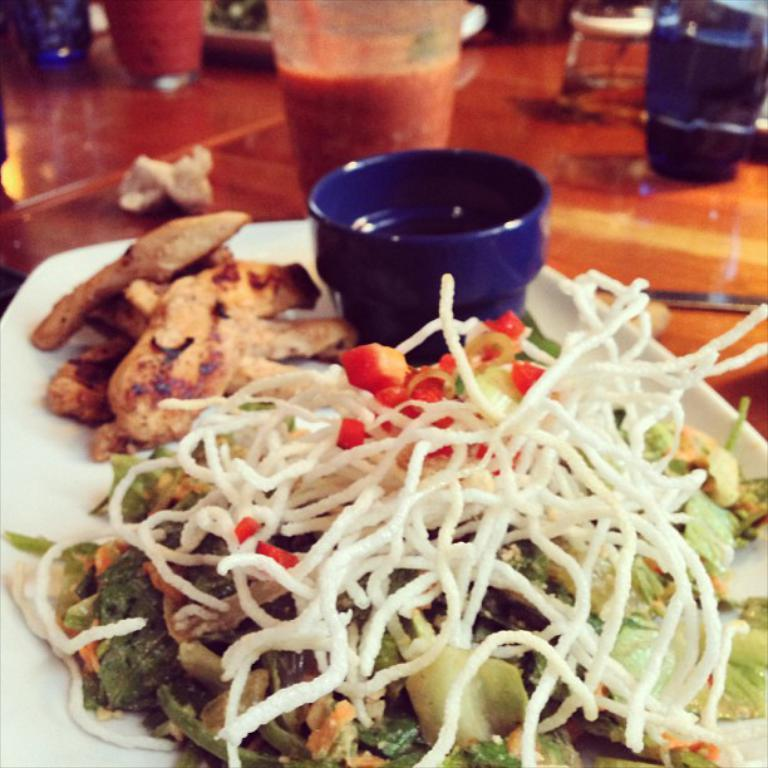What type of dishware can be seen in the image? There are plates and glasses in the image. What else is present in the image besides dishware? There is food in the image. On what surface are the plates, glasses, and food placed? The objects are placed on a wooden surface in the image. What type of jewel is present on the plate in the image? There is no jewel present on the plate in the image; it contains food. 